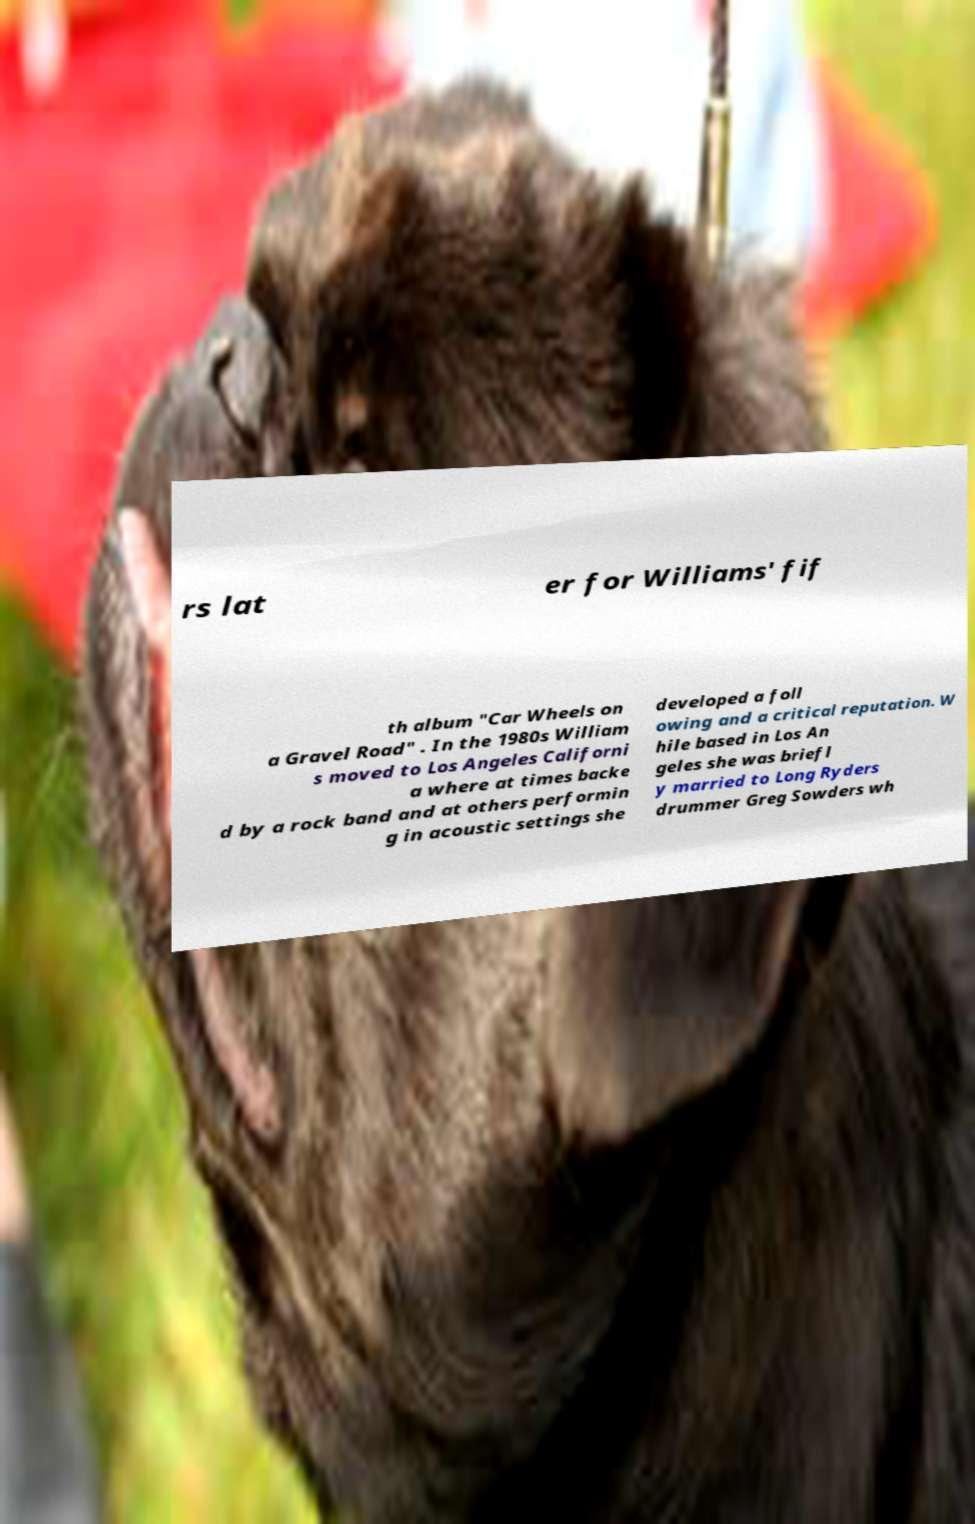There's text embedded in this image that I need extracted. Can you transcribe it verbatim? rs lat er for Williams' fif th album "Car Wheels on a Gravel Road" . In the 1980s William s moved to Los Angeles Californi a where at times backe d by a rock band and at others performin g in acoustic settings she developed a foll owing and a critical reputation. W hile based in Los An geles she was briefl y married to Long Ryders drummer Greg Sowders wh 